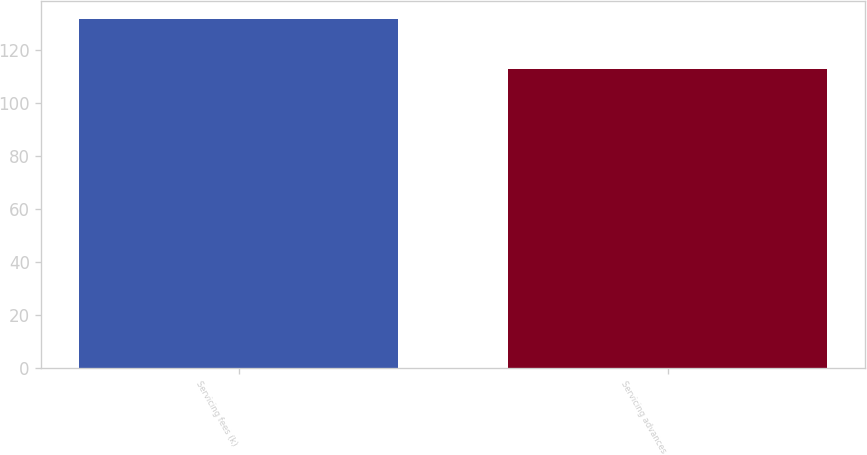Convert chart to OTSL. <chart><loc_0><loc_0><loc_500><loc_500><bar_chart><fcel>Servicing fees (k)<fcel>Servicing advances<nl><fcel>132<fcel>113<nl></chart> 